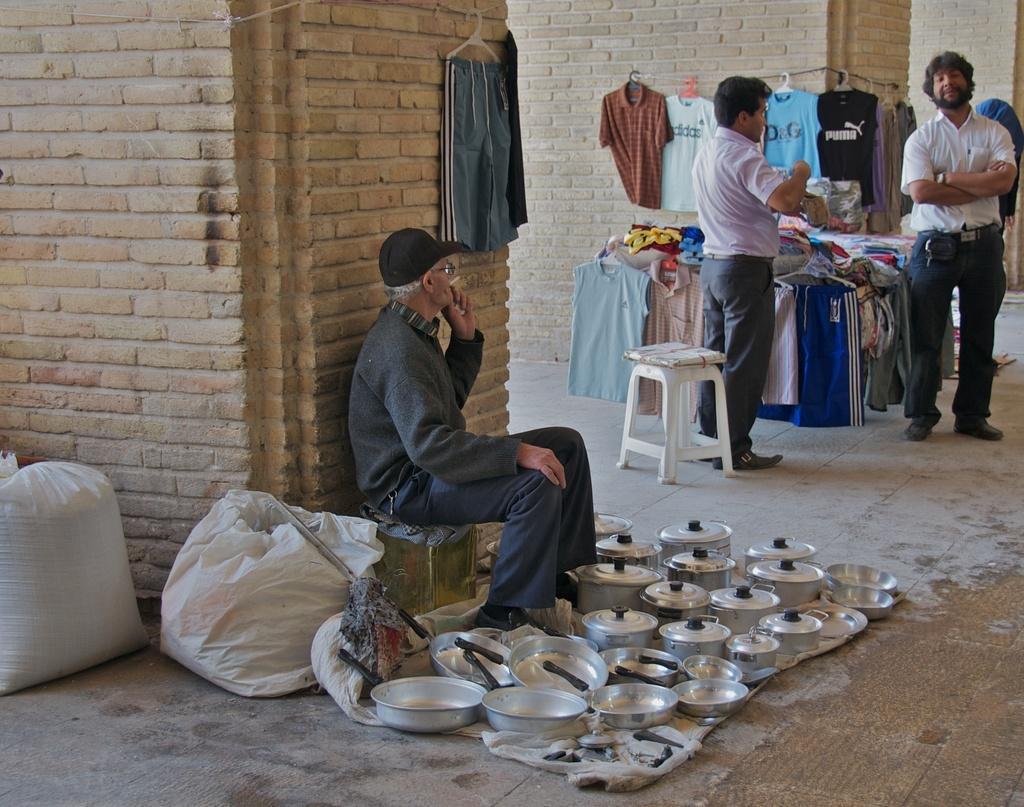Could you give a brief overview of what you see in this image? In the foreground of the picture there are kitchen utensils, mat, floor, bags, person, stool, hanger, cloth and brick wall. In the middle of the picture there are people, clothes, stool and other objects. In the background we can see brick walls. 